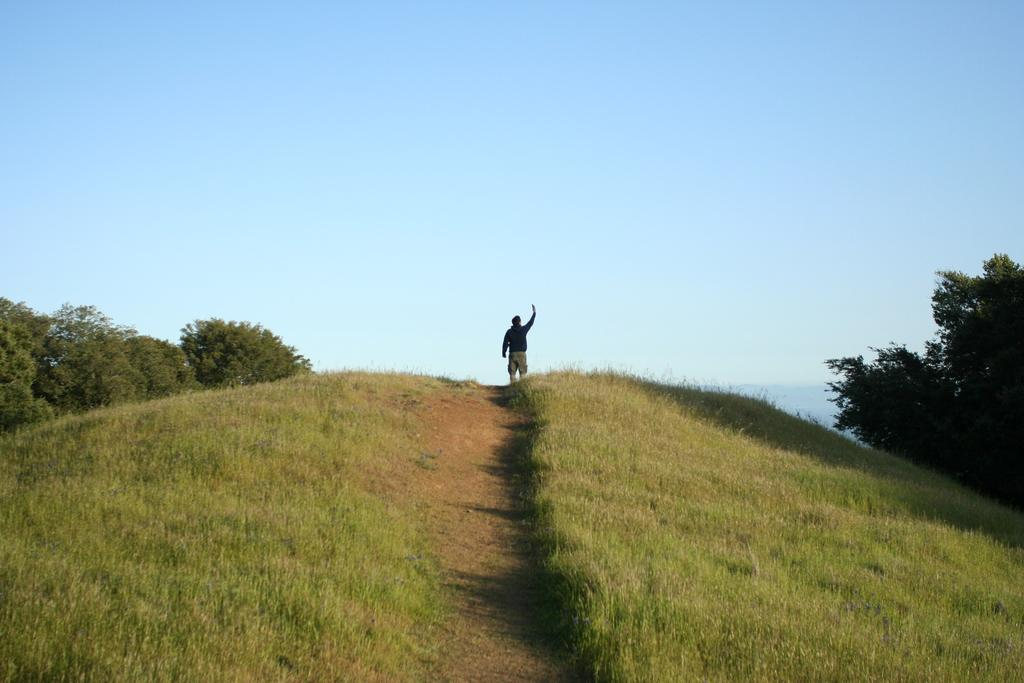What is the person in the image doing? The person is standing on the path in the image. What type of vegetation can be seen on both sides of the path? There is grass on the left and right sides of the image. What other natural elements are present in the image? There are trees on the left and right sides of the image. What can be seen in the distance behind the person and the trees? The sky is visible in the background of the image. What type of arch can be seen in the image? There is no arch present in the image. What is the person's home like in the image? The image does not show the person's home, only their location on a path surrounded by grass, trees, and sky. 